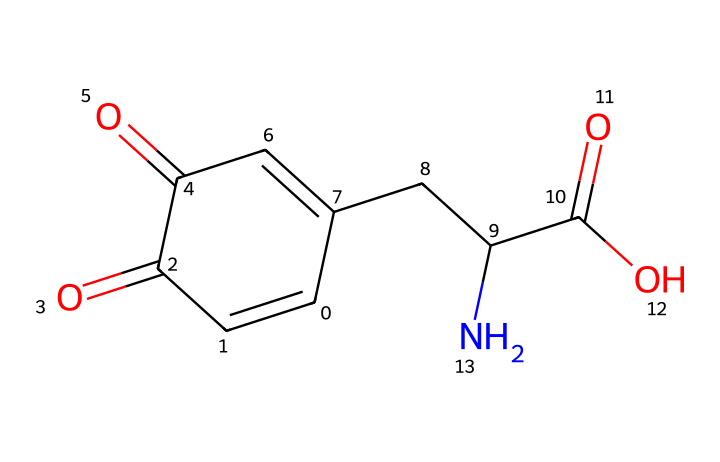how many carbon atoms are present in the compound? The SMILES representation includes multiple carbon atoms connected in various ways. By counting each "C" in the SMILES string, there are a total of 10 carbon atoms.
Answer: 10 what functional groups are present in the structure? Analyzing the structure reveals the presence of a carboxylic acid group (-COOH), indicated by "C(=O)O," and an amine group (-NH), as shown by the "N" in the SMILES.
Answer: carboxylic acid and amine what is the total number of double bonds in the chemical? The SMILES shows multiple "=" signs indicating double bonds. In total, there are four double bonds present in the structure.
Answer: 4 what type of compound does this structure represent? The presence of both the aromatic ring and specific functional groups suggests this chemical is a type of dye, specifically related to the molecular structure associated with melanin.
Answer: dye which atoms are involved in the ring structure of this compound? By examining the SMILES, the cyclic part of the molecule consists solely of carbon atoms, indicated by 'C1' at the beginning of the ring. The atoms within the ring are all carbon.
Answer: carbon 